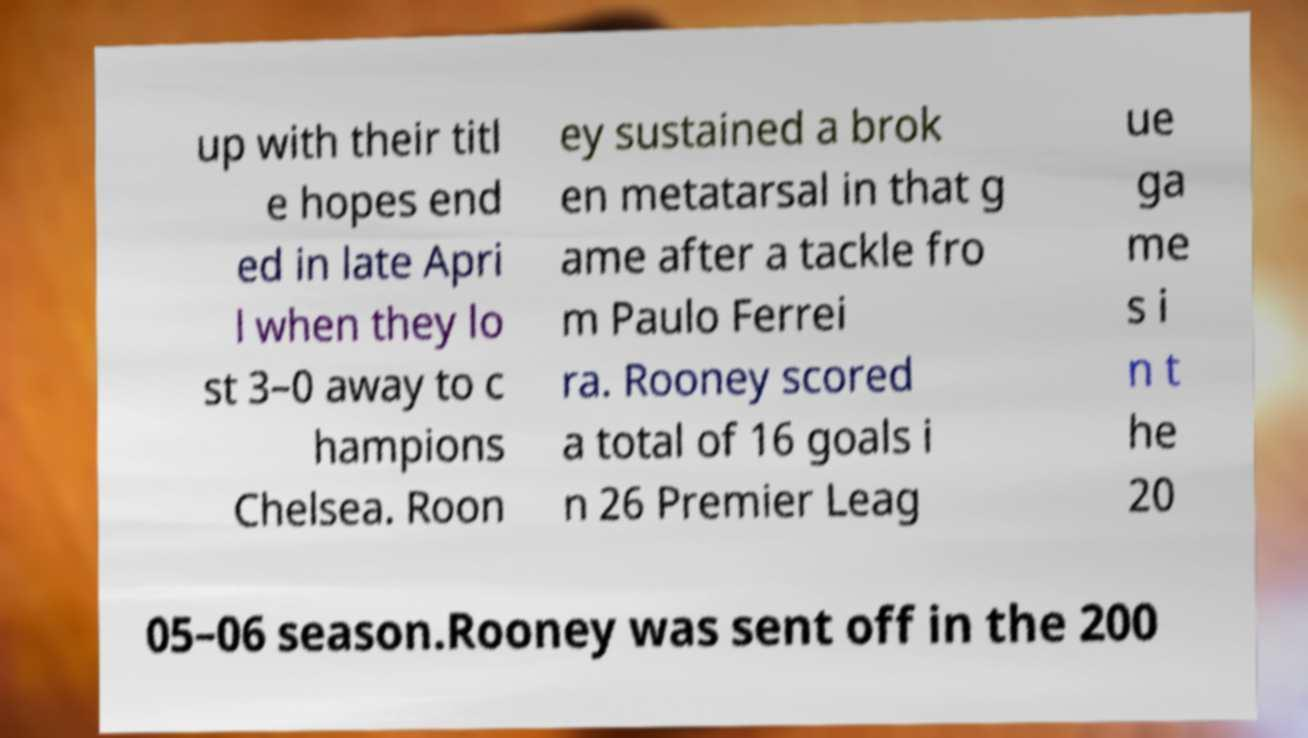Could you extract and type out the text from this image? up with their titl e hopes end ed in late Apri l when they lo st 3–0 away to c hampions Chelsea. Roon ey sustained a brok en metatarsal in that g ame after a tackle fro m Paulo Ferrei ra. Rooney scored a total of 16 goals i n 26 Premier Leag ue ga me s i n t he 20 05–06 season.Rooney was sent off in the 200 